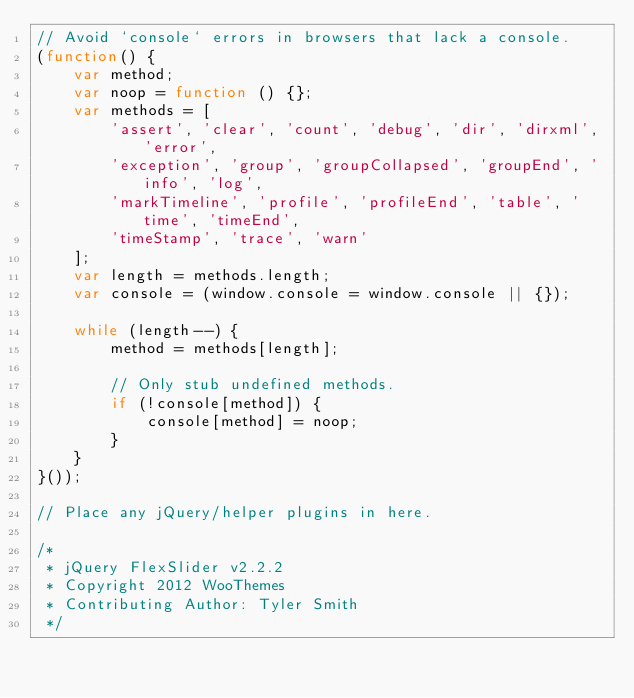<code> <loc_0><loc_0><loc_500><loc_500><_JavaScript_>// Avoid `console` errors in browsers that lack a console.
(function() {
    var method;
    var noop = function () {};
    var methods = [
        'assert', 'clear', 'count', 'debug', 'dir', 'dirxml', 'error',
        'exception', 'group', 'groupCollapsed', 'groupEnd', 'info', 'log',
        'markTimeline', 'profile', 'profileEnd', 'table', 'time', 'timeEnd',
        'timeStamp', 'trace', 'warn'
    ];
    var length = methods.length;
    var console = (window.console = window.console || {});

    while (length--) {
        method = methods[length];

        // Only stub undefined methods.
        if (!console[method]) {
            console[method] = noop;
        }
    }
}());

// Place any jQuery/helper plugins in here.

/*
 * jQuery FlexSlider v2.2.2
 * Copyright 2012 WooThemes
 * Contributing Author: Tyler Smith
 */</code> 